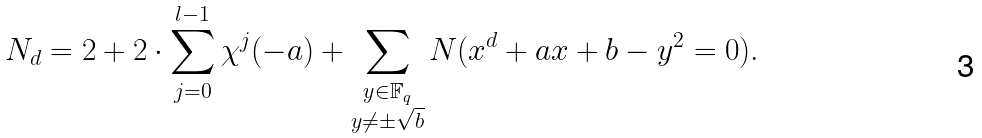Convert formula to latex. <formula><loc_0><loc_0><loc_500><loc_500>N _ { d } & = 2 + 2 \cdot \sum _ { j = 0 } ^ { l - 1 } \chi ^ { j } ( - a ) + \sum _ { \substack { y \in \mathbb { F } _ { q } \\ y \neq \pm \sqrt { b } } } N ( x ^ { d } + a x + b - y ^ { 2 } = 0 ) .</formula> 